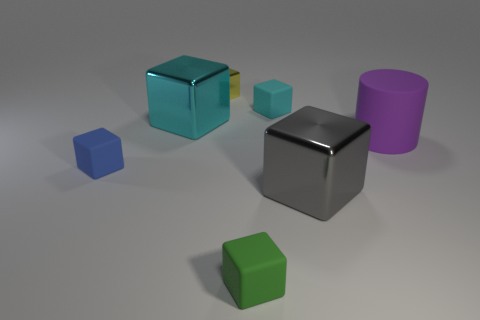There is a gray object that is the same size as the purple cylinder; what is its material?
Provide a short and direct response. Metal. Is there a gray cube of the same size as the blue matte block?
Keep it short and to the point. No. What is the material of the large object that is behind the large purple rubber cylinder?
Your answer should be very brief. Metal. Is the large block in front of the matte cylinder made of the same material as the large cyan object?
Your response must be concise. Yes. There is a matte thing that is the same size as the cyan metal thing; what is its shape?
Provide a succinct answer. Cylinder. Is the number of tiny blue blocks to the right of the blue cube less than the number of small matte blocks that are left of the yellow cube?
Your answer should be compact. Yes. Are there any tiny matte blocks behind the purple rubber cylinder?
Offer a terse response. Yes. There is a thing behind the matte cube that is behind the purple rubber cylinder; are there any tiny blue things behind it?
Ensure brevity in your answer.  No. Do the matte object that is left of the yellow thing and the large purple object have the same shape?
Your response must be concise. No. What color is the cylinder that is the same material as the green block?
Ensure brevity in your answer.  Purple. 